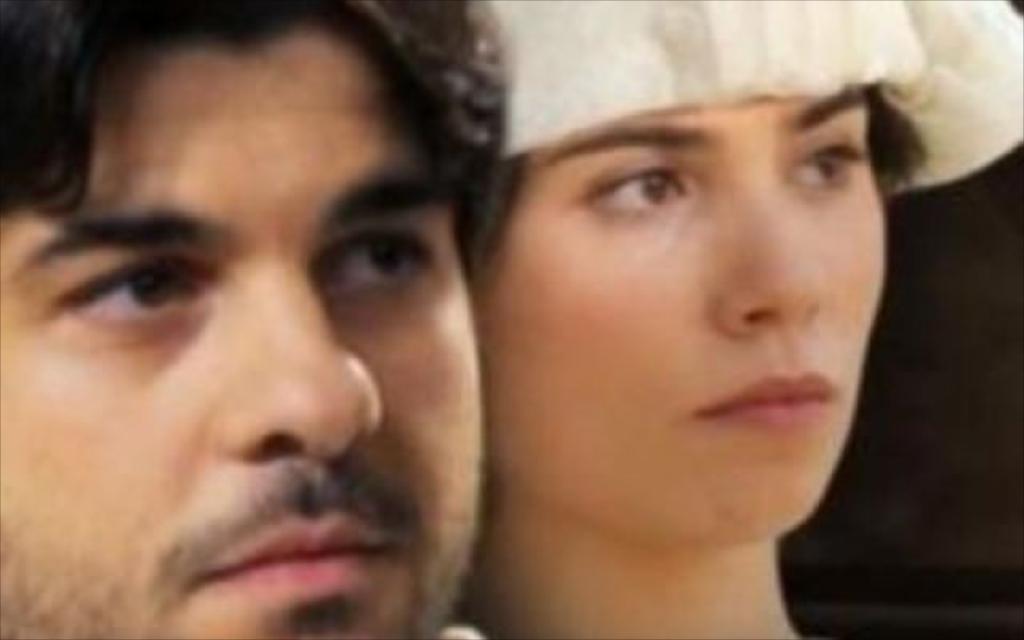Describe this image in one or two sentences. In this picture, we can see face of a boy and the girl, and we can see dark background. 